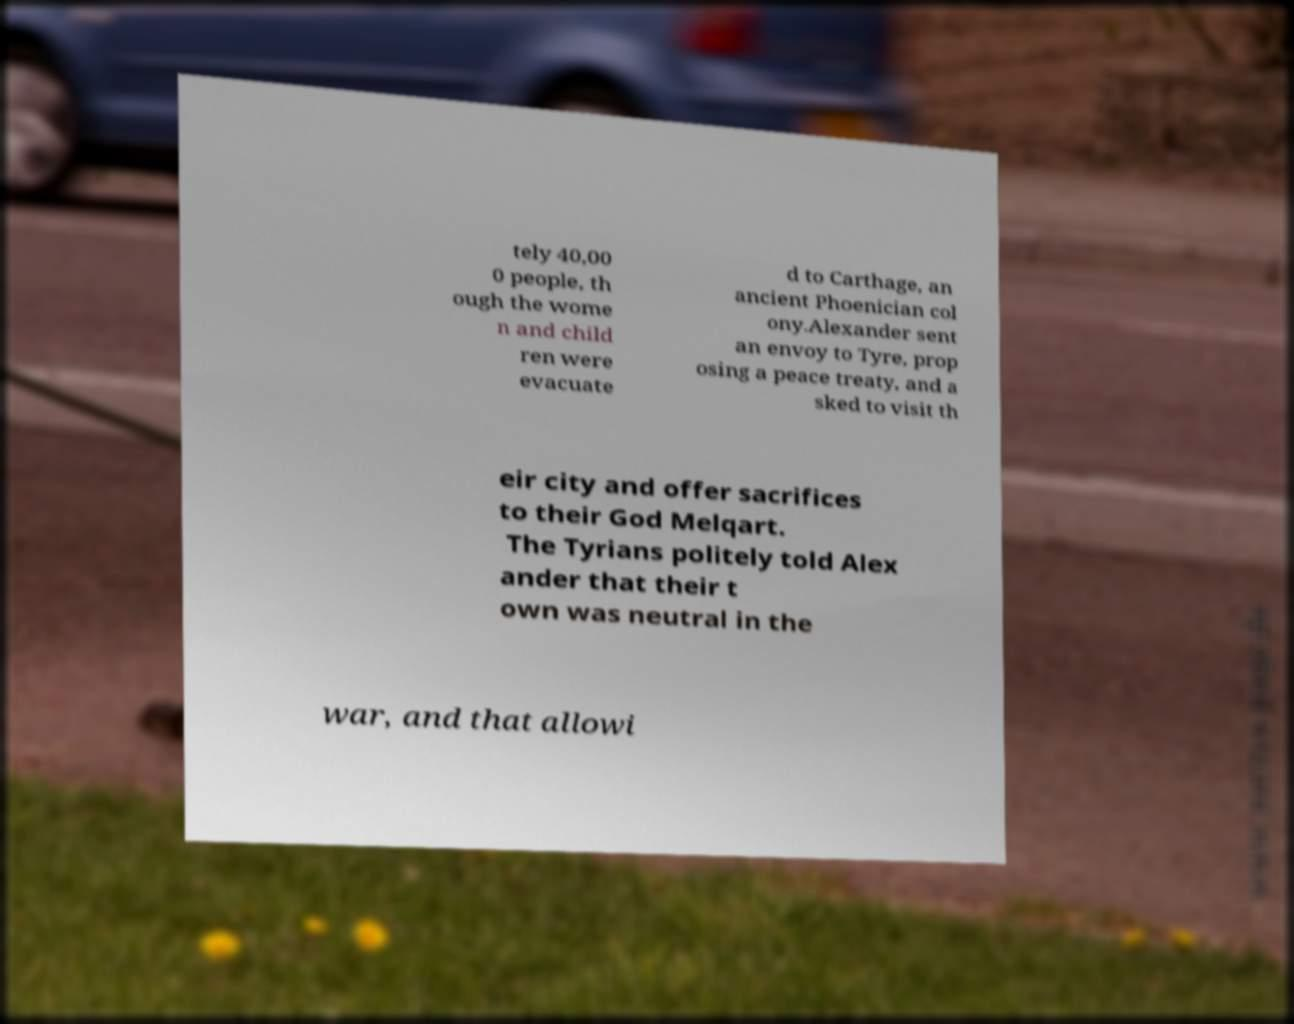I need the written content from this picture converted into text. Can you do that? tely 40,00 0 people, th ough the wome n and child ren were evacuate d to Carthage, an ancient Phoenician col ony.Alexander sent an envoy to Tyre, prop osing a peace treaty, and a sked to visit th eir city and offer sacrifices to their God Melqart. The Tyrians politely told Alex ander that their t own was neutral in the war, and that allowi 